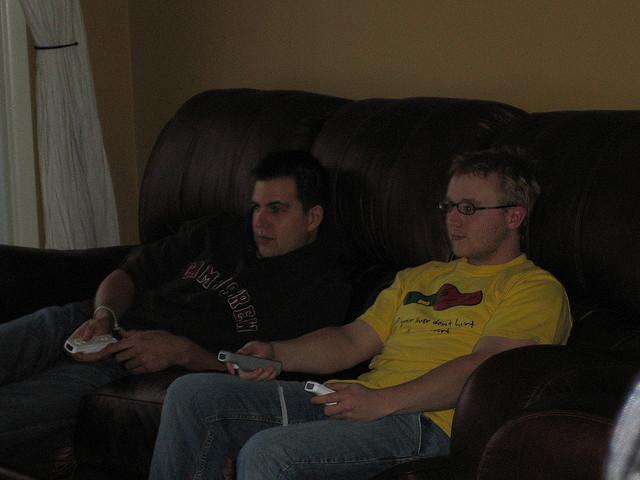How many people are wearing glasses?
Give a very brief answer. 1. How many rings is the man wearing?
Give a very brief answer. 0. How many curtains are there?
Give a very brief answer. 1. How many people are there?
Give a very brief answer. 2. How many different types of cakes are there?
Give a very brief answer. 0. 